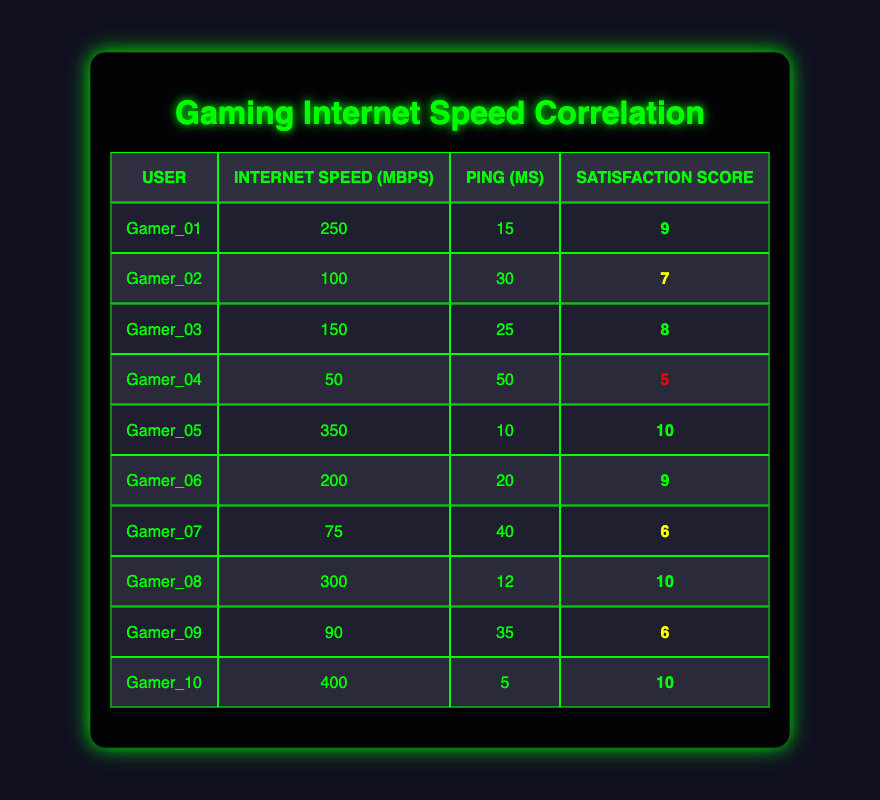What is the internet speed of Gamer_05? The table lists Gamer_05's details, specifically showing the column for Internet Speed. The speed provided for Gamer_05 is 350 Mbps.
Answer: 350 Mbps Which gamer has the lowest satisfaction score? By comparing the satisfaction scores in the table, I note Gamer_04 has a score of 5, which is lower than all other scores.
Answer: Gamer_04 What is the average internet speed of all gamers? To calculate the average internet speed, sum all the speeds: (250 + 100 + 150 + 50 + 350 + 200 + 75 + 300 + 90 + 400) = 1965 Mbps. Then divide by the number of users (10): 1965 / 10 = 196.5 Mbps.
Answer: 196.5 Mbps Is Gamer_10's satisfaction score greater than 8? Checking Gamer_10's satisfaction score in the table shows it is 10, which is indeed greater than 8.
Answer: Yes What is the difference between the highest and lowest satisfaction scores? The highest satisfaction score is 10 (Gamer_05, Gamer_08, and Gamer_10), and the lowest is 5 (Gamer_04). Therefore, the difference is 10 - 5 = 5.
Answer: 5 How many gamers have an internet speed over 200 Mbps? The table shows the following gamers with internet speeds over 200 Mbps: Gamer_01 (250 Mbps), Gamer_05 (350 Mbps), Gamer_06 (200 Mbps), Gamer_08 (300 Mbps), and Gamer_10 (400 Mbps), which totals 5 gamers.
Answer: 5 Which gamer has the highest ping score? Looking at the ping scores in the table, Gamer_04 has the highest ping score of 50 ms.
Answer: Gamer_04 What is the average satisfaction score for gamers with internet speeds below 100 Mbps? The only gamer with internet speed below 100 Mbps is Gamer_04, with a satisfaction score of 5. Therefore, the average is 5.
Answer: 5 If we consider gamers with satisfaction scores of 9 or 10, how many have internet speeds above 250 Mbps? The gamers with scores of 9 or 10 are Gamer_01 (250 Mbps, score 9), Gamer_05 (350 Mbps, score 10), Gamer_06 (200 Mbps, score 9), Gamer_08 (300 Mbps, score 10), and Gamer_10 (400 Mbps, score 10). The relevant gamers with speeds above 250 Mbps are Gamer_05 (350 Mbps) and Gamer_10 (400 Mbps), totaling 2 gamers.
Answer: 2 